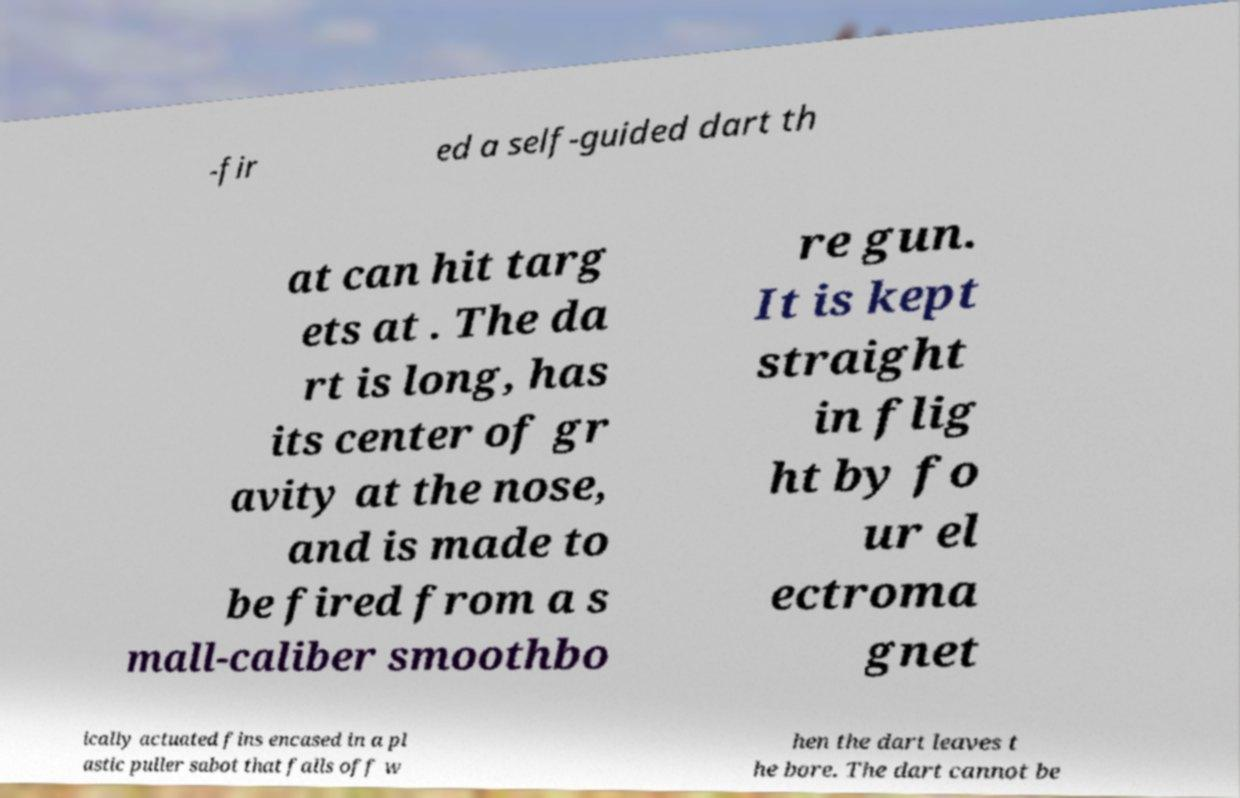Could you extract and type out the text from this image? -fir ed a self-guided dart th at can hit targ ets at . The da rt is long, has its center of gr avity at the nose, and is made to be fired from a s mall-caliber smoothbo re gun. It is kept straight in flig ht by fo ur el ectroma gnet ically actuated fins encased in a pl astic puller sabot that falls off w hen the dart leaves t he bore. The dart cannot be 